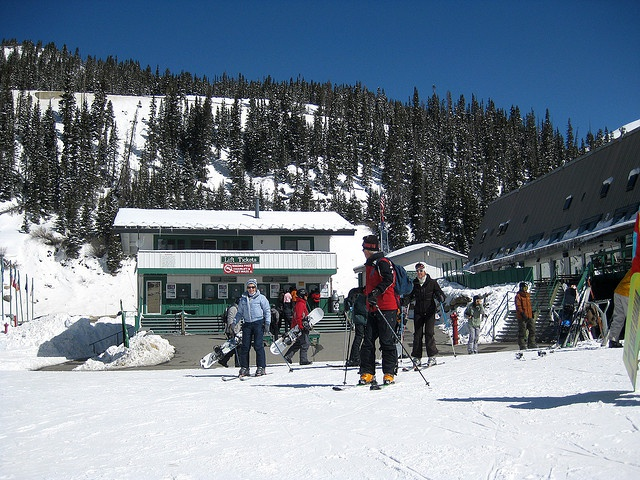Describe the objects in this image and their specific colors. I can see people in navy, black, maroon, gray, and brown tones, people in navy, black, and gray tones, people in navy, black, gray, and darkgray tones, snowboard in navy, black, gray, white, and darkgray tones, and people in navy, black, gray, darkgray, and purple tones in this image. 